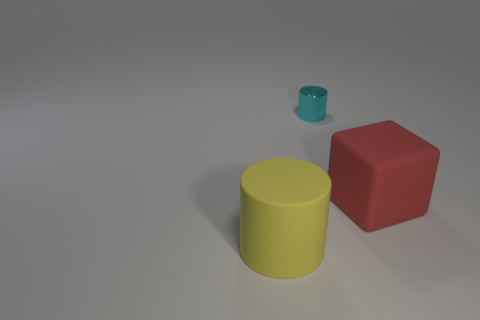Add 3 small metal cylinders. How many objects exist? 6 Subtract all cylinders. How many objects are left? 1 Subtract all big blocks. Subtract all big red things. How many objects are left? 1 Add 3 small cyan shiny things. How many small cyan shiny things are left? 4 Add 1 large brown matte cylinders. How many large brown matte cylinders exist? 1 Subtract 0 yellow cubes. How many objects are left? 3 